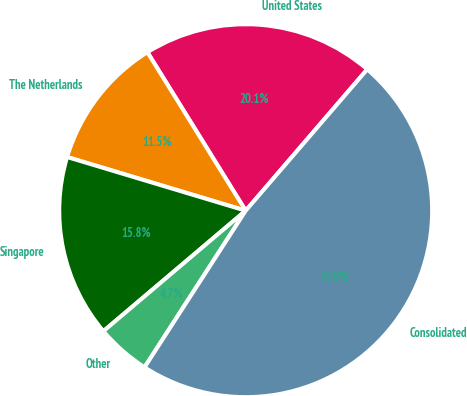Convert chart to OTSL. <chart><loc_0><loc_0><loc_500><loc_500><pie_chart><fcel>United States<fcel>The Netherlands<fcel>Singapore<fcel>Other<fcel>Consolidated<nl><fcel>20.14%<fcel>11.52%<fcel>15.83%<fcel>4.69%<fcel>47.82%<nl></chart> 